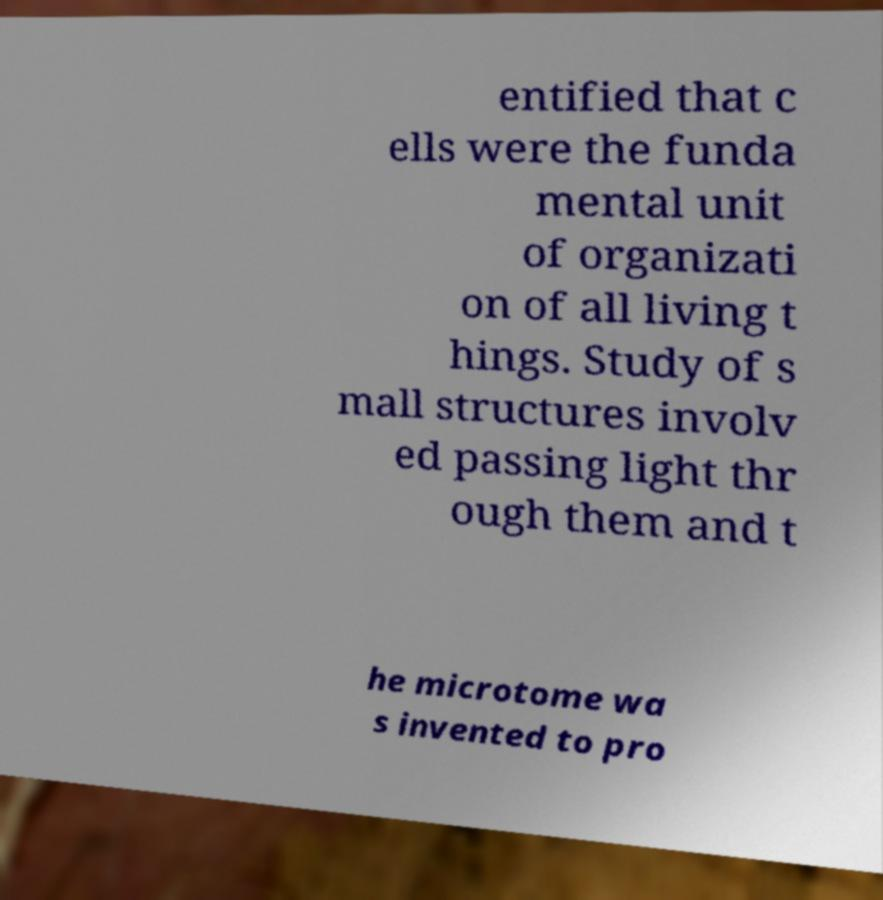Please identify and transcribe the text found in this image. entified that c ells were the funda mental unit of organizati on of all living t hings. Study of s mall structures involv ed passing light thr ough them and t he microtome wa s invented to pro 